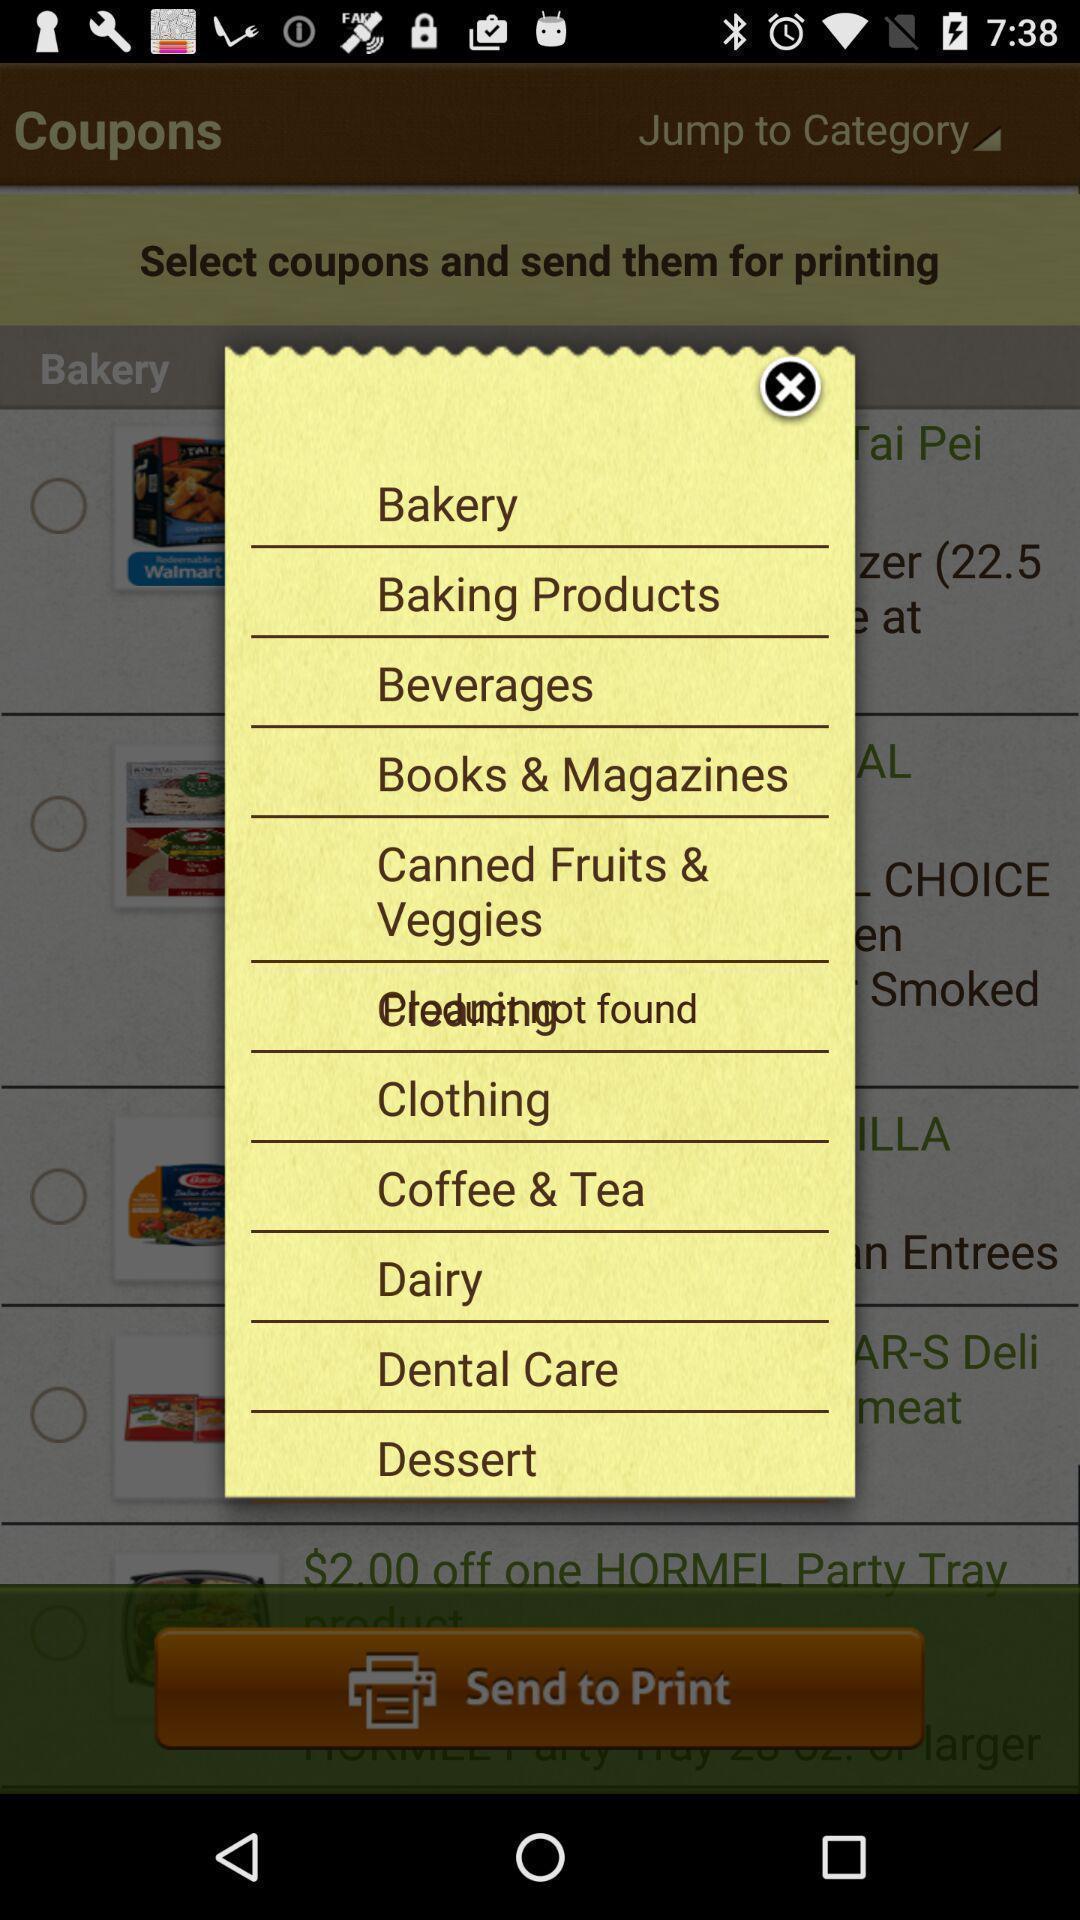Provide a description of this screenshot. Pop-up shows different options. 